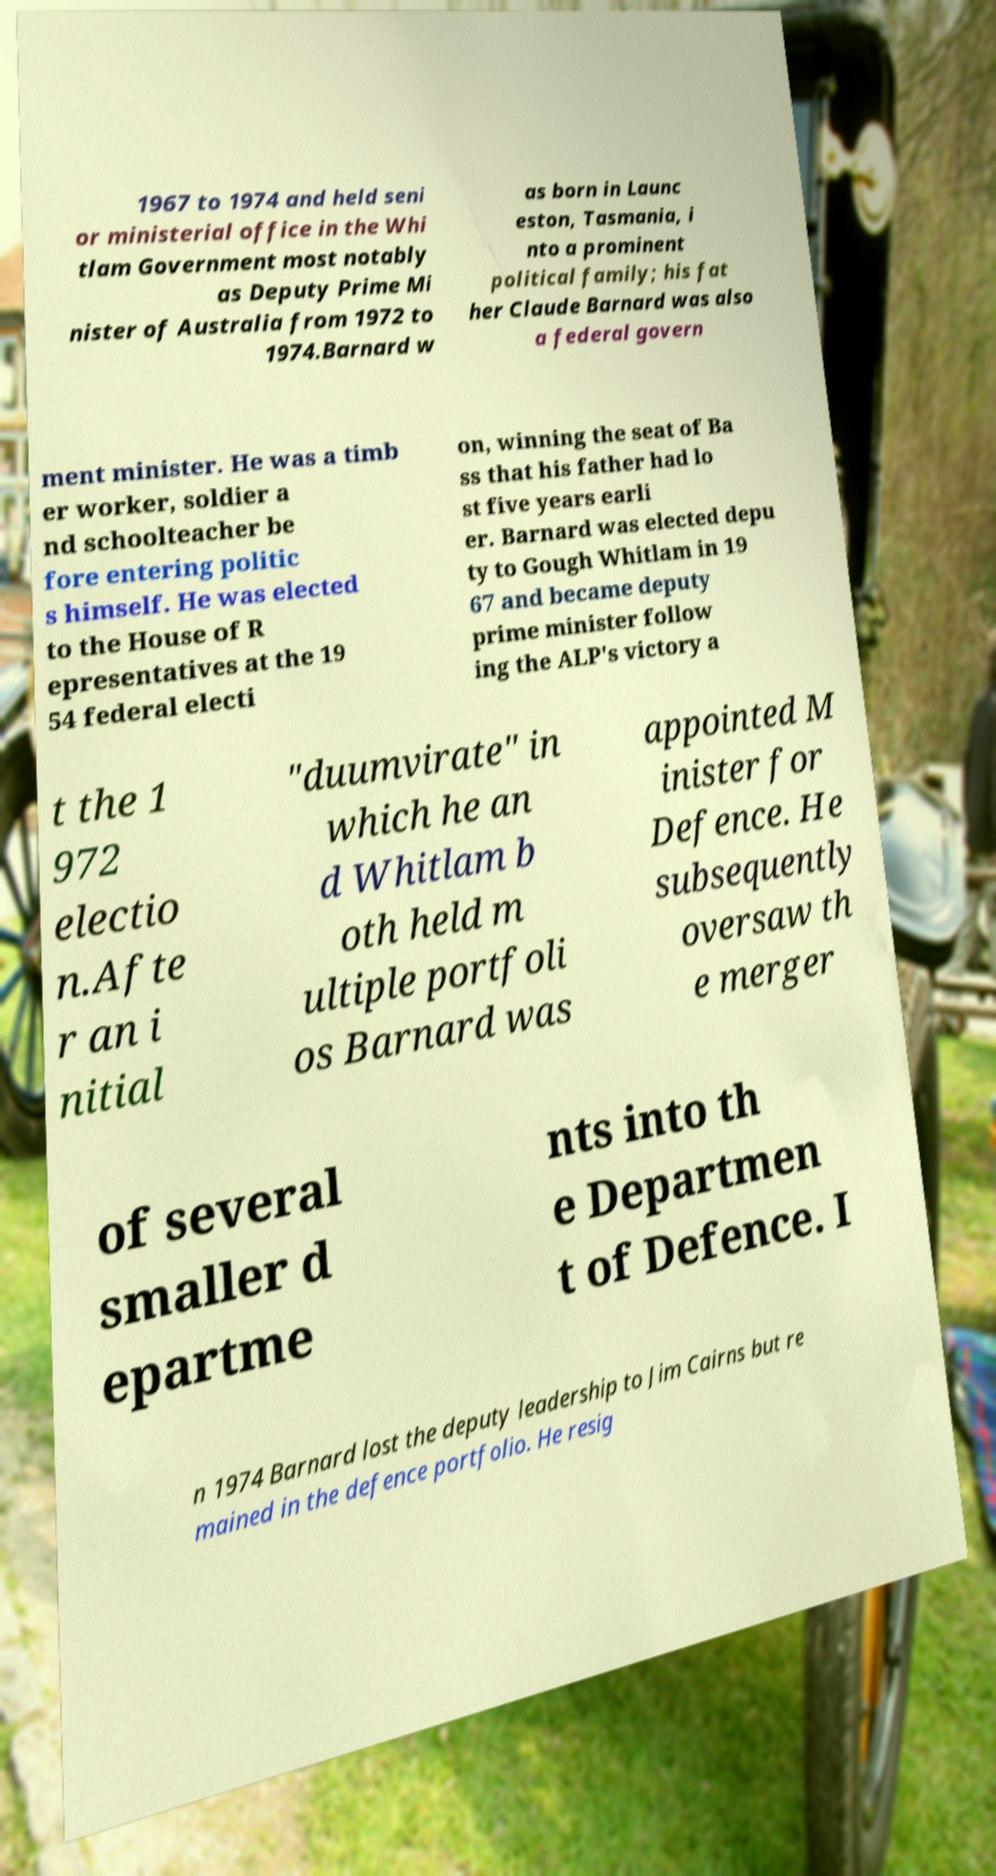Could you extract and type out the text from this image? 1967 to 1974 and held seni or ministerial office in the Whi tlam Government most notably as Deputy Prime Mi nister of Australia from 1972 to 1974.Barnard w as born in Launc eston, Tasmania, i nto a prominent political family; his fat her Claude Barnard was also a federal govern ment minister. He was a timb er worker, soldier a nd schoolteacher be fore entering politic s himself. He was elected to the House of R epresentatives at the 19 54 federal electi on, winning the seat of Ba ss that his father had lo st five years earli er. Barnard was elected depu ty to Gough Whitlam in 19 67 and became deputy prime minister follow ing the ALP's victory a t the 1 972 electio n.Afte r an i nitial "duumvirate" in which he an d Whitlam b oth held m ultiple portfoli os Barnard was appointed M inister for Defence. He subsequently oversaw th e merger of several smaller d epartme nts into th e Departmen t of Defence. I n 1974 Barnard lost the deputy leadership to Jim Cairns but re mained in the defence portfolio. He resig 